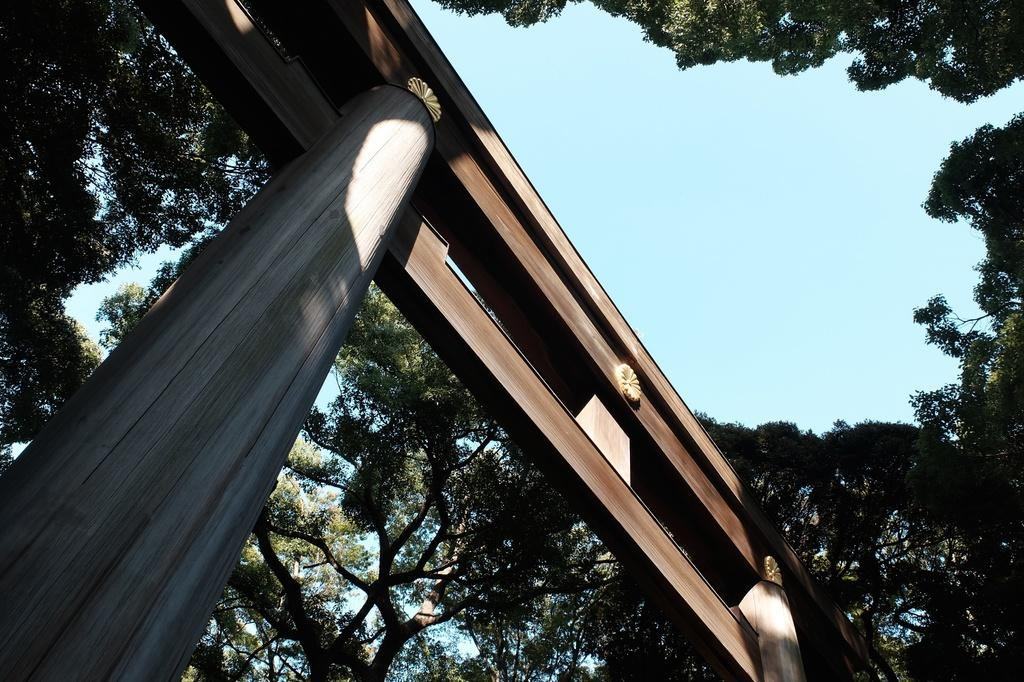What is the main object in the image? There is a wooden pole in the image. Are there any other wooden objects associated with the pole? Yes, there are wooden boards associated with the pole. What can be seen in the background of the image? There are trees and the sky visible in the background of the image. What is the price of the cream being sold near the wooden pole in the image? There is no cream or any indication of a sale in the image. 